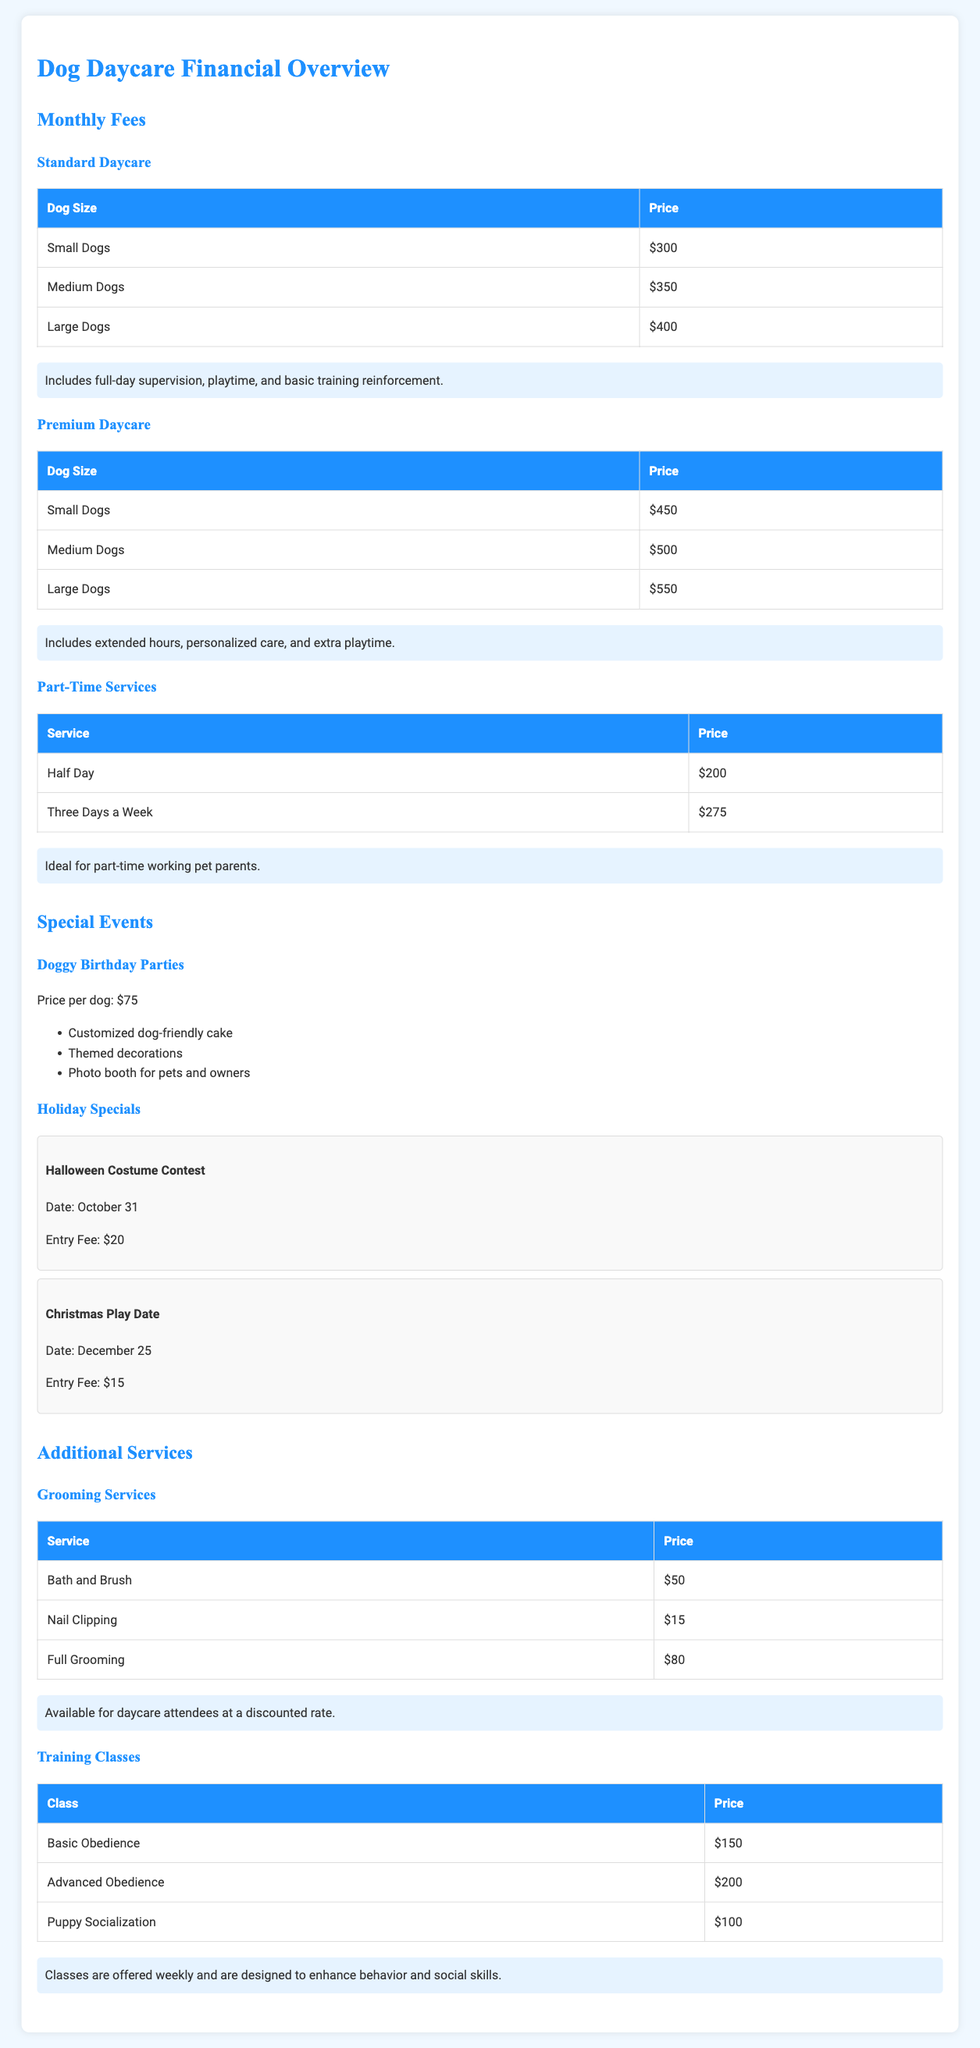What is the monthly fee for large dogs in Standard Daycare? The fee is listed in the Standard Daycare section of the document specifically for large dogs.
Answer: $400 How much do doggy birthday parties cost per dog? The price is stated under the Special Events section for doggy birthday parties.
Answer: $75 What is the entry fee for the Halloween Costume Contest? The fee is provided in the Holiday Specials section as the entry fee for this specific event.
Answer: $20 What additional service is available for daycare attendees at a discounted rate? This is mentioned under Additional Services, specifically related to grooming.
Answer: Grooming Services How many special events are listed in the document? The Special Events section details two specific events.
Answer: 2 